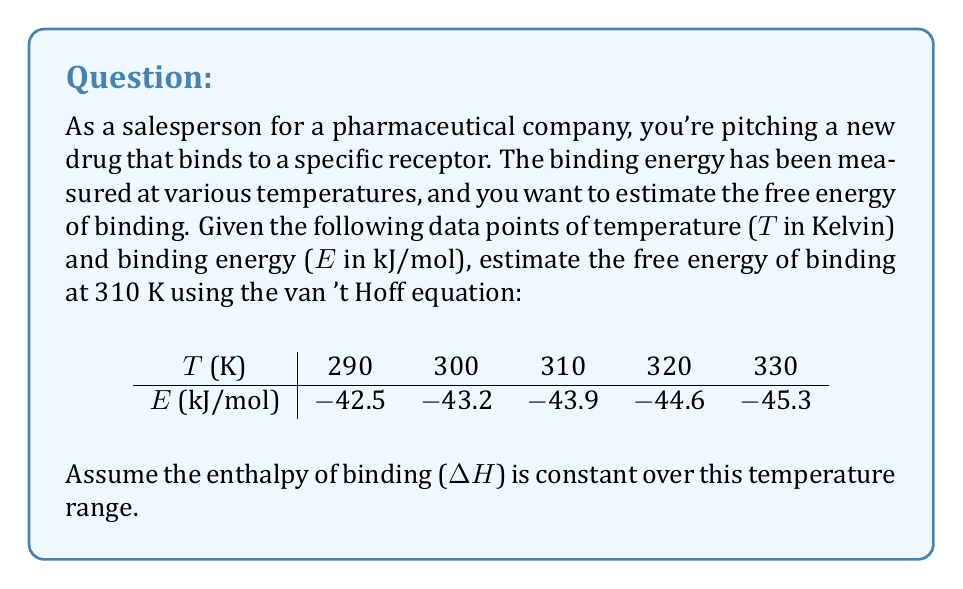Give your solution to this math problem. To estimate the free energy of drug-receptor binding, we'll use the van 't Hoff equation and the given data. Here's the step-by-step process:

1) The van 't Hoff equation relates the equilibrium constant K to temperature T:

   $$\frac{d\ln K}{dT} = \frac{\Delta H}{RT^2}$$

2) Integrating this equation between two temperatures T₁ and T₂:

   $$\ln\frac{K_2}{K_1} = -\frac{\Delta H}{R}\left(\frac{1}{T_2} - \frac{1}{T_1}\right)$$

3) The binding energy E is related to the equilibrium constant K by:

   $$E = -RT\ln K$$

4) Substituting this into the integrated van 't Hoff equation:

   $$\frac{E_2}{RT_2} - \frac{E_1}{RT_1} = \frac{\Delta H}{R}\left(\frac{1}{T_2} - \frac{1}{T_1}\right)$$

5) We can use any two data points to calculate ΔH. Let's use the first and last:

   $$\frac{-45.3}{8.314 \cdot 330} - \frac{-42.5}{8.314 \cdot 290} = \frac{\Delta H}{8.314}\left(\frac{1}{330} - \frac{1}{290}\right)$$

6) Solving for ΔH:

   $$\Delta H \approx -51.8 \text{ kJ/mol}$$

7) Now we can use this ΔH value to calculate the free energy at 310 K:

   $$\frac{E_{310}}{R \cdot 310} - \frac{-42.5}{R \cdot 290} = \frac{-51800}{R}\left(\frac{1}{310} - \frac{1}{290}\right)$$

8) Solving for E₃₁₀:

   $$E_{310} \approx -43.9 \text{ kJ/mol}$$

9) The free energy (ΔG) is equal to the binding energy (E) at a given temperature:

   $$\Delta G_{310} = -43.9 \text{ kJ/mol}$$
Answer: $\Delta G_{310} = -43.9 \text{ kJ/mol}$ 